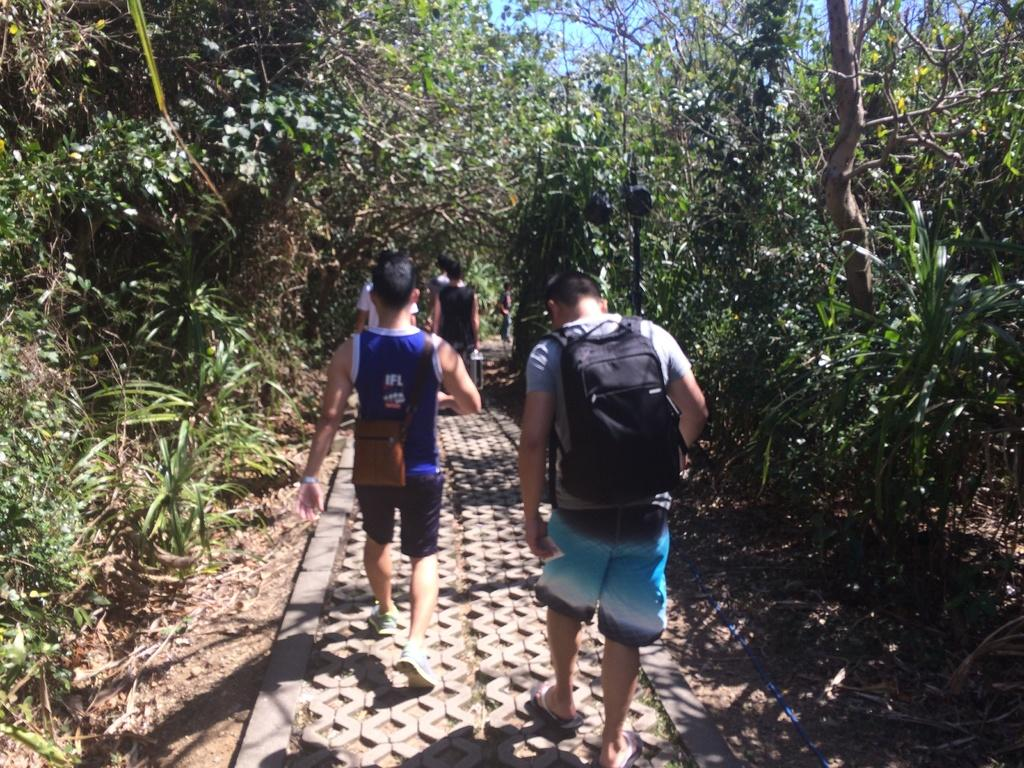What are the people in the image doing? The people in the image are walking. What type of natural elements can be seen in the image? There are plants and trees in the image. What type of soda is being served at the event in the image? There is no event or soda present in the image; it only shows people walking and plants/trees. 